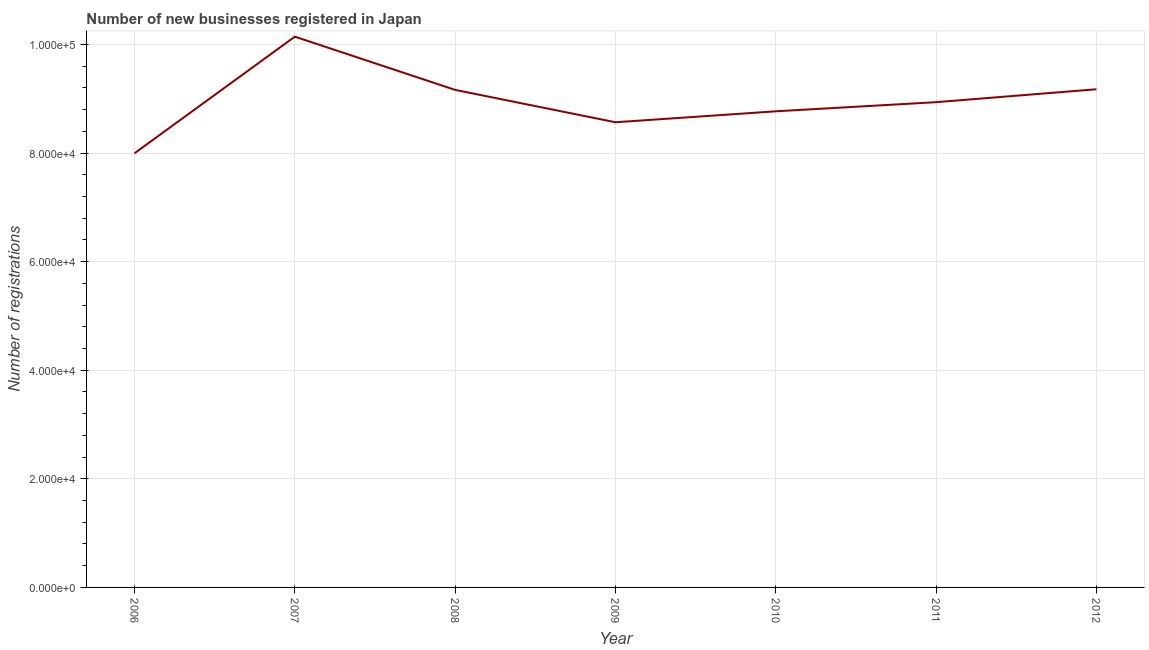What is the number of new business registrations in 2007?
Offer a very short reply. 1.01e+05. Across all years, what is the maximum number of new business registrations?
Offer a terse response. 1.01e+05. Across all years, what is the minimum number of new business registrations?
Make the answer very short. 8.00e+04. In which year was the number of new business registrations maximum?
Provide a short and direct response. 2007. In which year was the number of new business registrations minimum?
Keep it short and to the point. 2006. What is the sum of the number of new business registrations?
Your response must be concise. 6.28e+05. What is the difference between the number of new business registrations in 2008 and 2009?
Ensure brevity in your answer.  5962. What is the average number of new business registrations per year?
Offer a very short reply. 8.96e+04. What is the median number of new business registrations?
Provide a short and direct response. 8.94e+04. Do a majority of the years between 2012 and 2007 (inclusive) have number of new business registrations greater than 96000 ?
Your answer should be compact. Yes. What is the ratio of the number of new business registrations in 2010 to that in 2012?
Offer a terse response. 0.96. Is the number of new business registrations in 2006 less than that in 2010?
Offer a terse response. Yes. What is the difference between the highest and the second highest number of new business registrations?
Your answer should be very brief. 9688. Is the sum of the number of new business registrations in 2008 and 2012 greater than the maximum number of new business registrations across all years?
Offer a terse response. Yes. What is the difference between the highest and the lowest number of new business registrations?
Provide a succinct answer. 2.15e+04. In how many years, is the number of new business registrations greater than the average number of new business registrations taken over all years?
Give a very brief answer. 3. Does the number of new business registrations monotonically increase over the years?
Make the answer very short. No. Does the graph contain any zero values?
Offer a terse response. No. Does the graph contain grids?
Ensure brevity in your answer.  Yes. What is the title of the graph?
Offer a very short reply. Number of new businesses registered in Japan. What is the label or title of the X-axis?
Keep it short and to the point. Year. What is the label or title of the Y-axis?
Provide a succinct answer. Number of registrations. What is the Number of registrations in 2006?
Provide a succinct answer. 8.00e+04. What is the Number of registrations in 2007?
Provide a succinct answer. 1.01e+05. What is the Number of registrations in 2008?
Offer a terse response. 9.16e+04. What is the Number of registrations in 2009?
Provide a succinct answer. 8.57e+04. What is the Number of registrations in 2010?
Offer a terse response. 8.77e+04. What is the Number of registrations in 2011?
Make the answer very short. 8.94e+04. What is the Number of registrations in 2012?
Your answer should be compact. 9.18e+04. What is the difference between the Number of registrations in 2006 and 2007?
Offer a terse response. -2.15e+04. What is the difference between the Number of registrations in 2006 and 2008?
Provide a succinct answer. -1.17e+04. What is the difference between the Number of registrations in 2006 and 2009?
Provide a short and direct response. -5711. What is the difference between the Number of registrations in 2006 and 2010?
Your response must be concise. -7726. What is the difference between the Number of registrations in 2006 and 2011?
Your response must be concise. -9411. What is the difference between the Number of registrations in 2006 and 2012?
Provide a short and direct response. -1.18e+04. What is the difference between the Number of registrations in 2007 and 2008?
Offer a very short reply. 9804. What is the difference between the Number of registrations in 2007 and 2009?
Provide a succinct answer. 1.58e+04. What is the difference between the Number of registrations in 2007 and 2010?
Offer a very short reply. 1.38e+04. What is the difference between the Number of registrations in 2007 and 2011?
Offer a terse response. 1.21e+04. What is the difference between the Number of registrations in 2007 and 2012?
Your answer should be very brief. 9688. What is the difference between the Number of registrations in 2008 and 2009?
Provide a short and direct response. 5962. What is the difference between the Number of registrations in 2008 and 2010?
Make the answer very short. 3947. What is the difference between the Number of registrations in 2008 and 2011?
Offer a terse response. 2262. What is the difference between the Number of registrations in 2008 and 2012?
Make the answer very short. -116. What is the difference between the Number of registrations in 2009 and 2010?
Provide a short and direct response. -2015. What is the difference between the Number of registrations in 2009 and 2011?
Keep it short and to the point. -3700. What is the difference between the Number of registrations in 2009 and 2012?
Provide a short and direct response. -6078. What is the difference between the Number of registrations in 2010 and 2011?
Provide a short and direct response. -1685. What is the difference between the Number of registrations in 2010 and 2012?
Provide a short and direct response. -4063. What is the difference between the Number of registrations in 2011 and 2012?
Your answer should be compact. -2378. What is the ratio of the Number of registrations in 2006 to that in 2007?
Keep it short and to the point. 0.79. What is the ratio of the Number of registrations in 2006 to that in 2008?
Keep it short and to the point. 0.87. What is the ratio of the Number of registrations in 2006 to that in 2009?
Give a very brief answer. 0.93. What is the ratio of the Number of registrations in 2006 to that in 2010?
Provide a short and direct response. 0.91. What is the ratio of the Number of registrations in 2006 to that in 2011?
Offer a very short reply. 0.9. What is the ratio of the Number of registrations in 2006 to that in 2012?
Your response must be concise. 0.87. What is the ratio of the Number of registrations in 2007 to that in 2008?
Your answer should be very brief. 1.11. What is the ratio of the Number of registrations in 2007 to that in 2009?
Your response must be concise. 1.18. What is the ratio of the Number of registrations in 2007 to that in 2010?
Provide a short and direct response. 1.16. What is the ratio of the Number of registrations in 2007 to that in 2011?
Provide a short and direct response. 1.14. What is the ratio of the Number of registrations in 2007 to that in 2012?
Your answer should be compact. 1.11. What is the ratio of the Number of registrations in 2008 to that in 2009?
Make the answer very short. 1.07. What is the ratio of the Number of registrations in 2008 to that in 2010?
Your answer should be compact. 1.04. What is the ratio of the Number of registrations in 2008 to that in 2012?
Offer a terse response. 1. What is the ratio of the Number of registrations in 2009 to that in 2012?
Provide a succinct answer. 0.93. What is the ratio of the Number of registrations in 2010 to that in 2012?
Your answer should be compact. 0.96. 